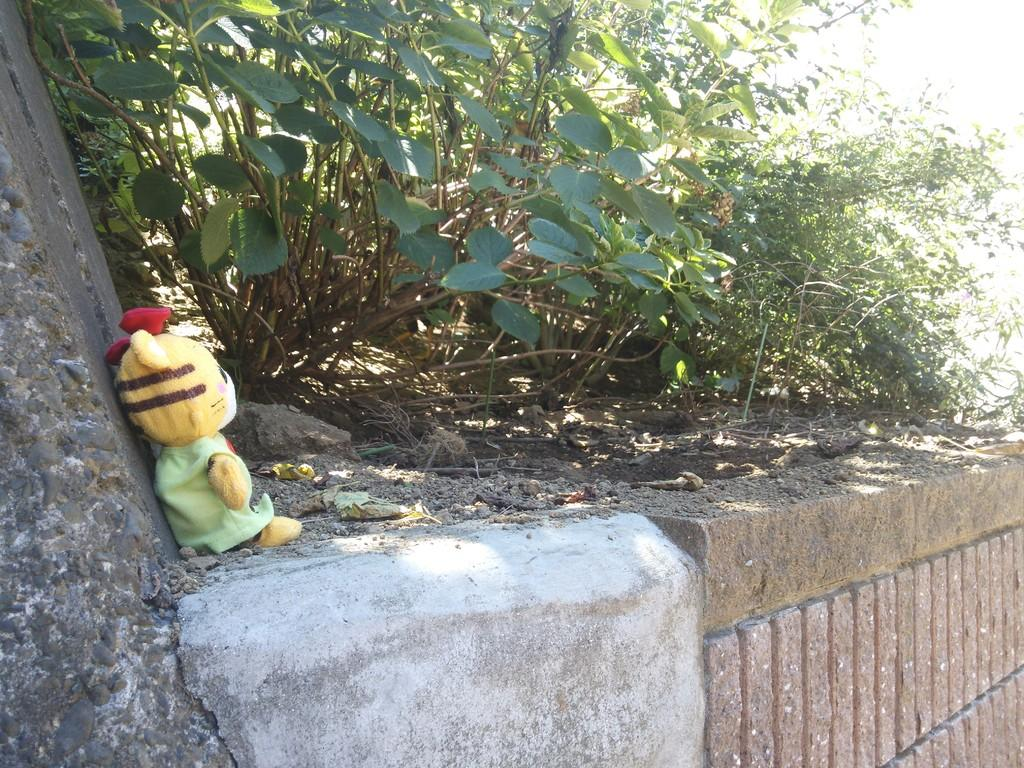What can be seen in the background of the image? There is a wall in the image. What is placed on top of the wall? There is a toy on top of the wall. What else is visible near the toy? There are plants beside the toy. What type of soup is being served in the image? There is no soup present in the image. 